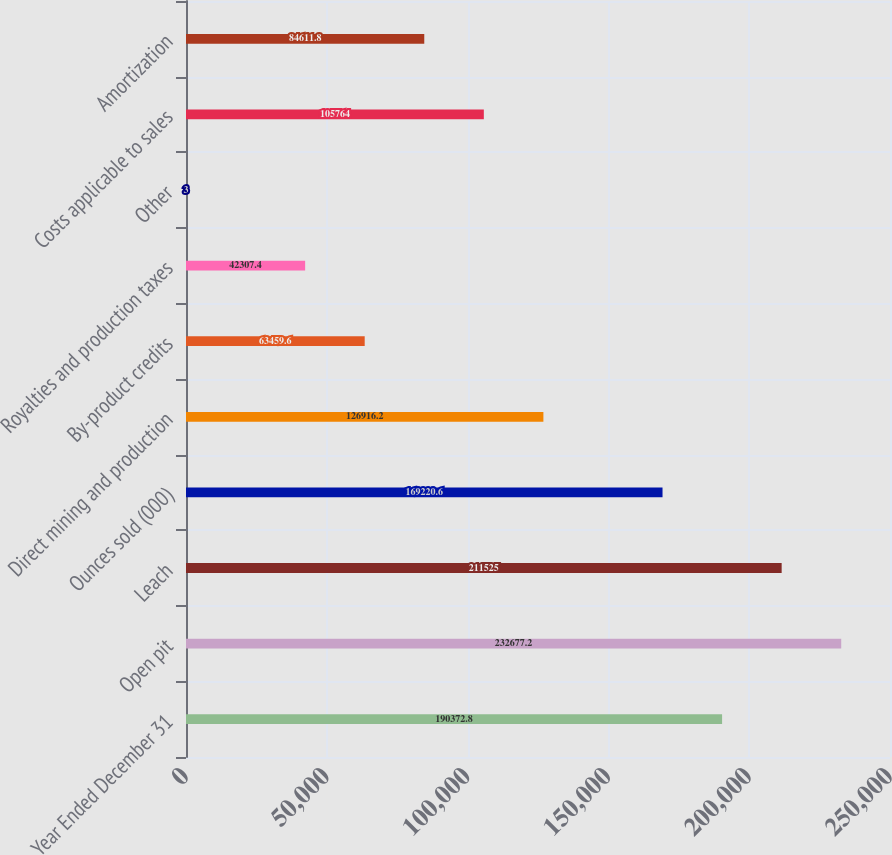<chart> <loc_0><loc_0><loc_500><loc_500><bar_chart><fcel>Year Ended December 31<fcel>Open pit<fcel>Leach<fcel>Ounces sold (000)<fcel>Direct mining and production<fcel>By-product credits<fcel>Royalties and production taxes<fcel>Other<fcel>Costs applicable to sales<fcel>Amortization<nl><fcel>190373<fcel>232677<fcel>211525<fcel>169221<fcel>126916<fcel>63459.6<fcel>42307.4<fcel>3<fcel>105764<fcel>84611.8<nl></chart> 